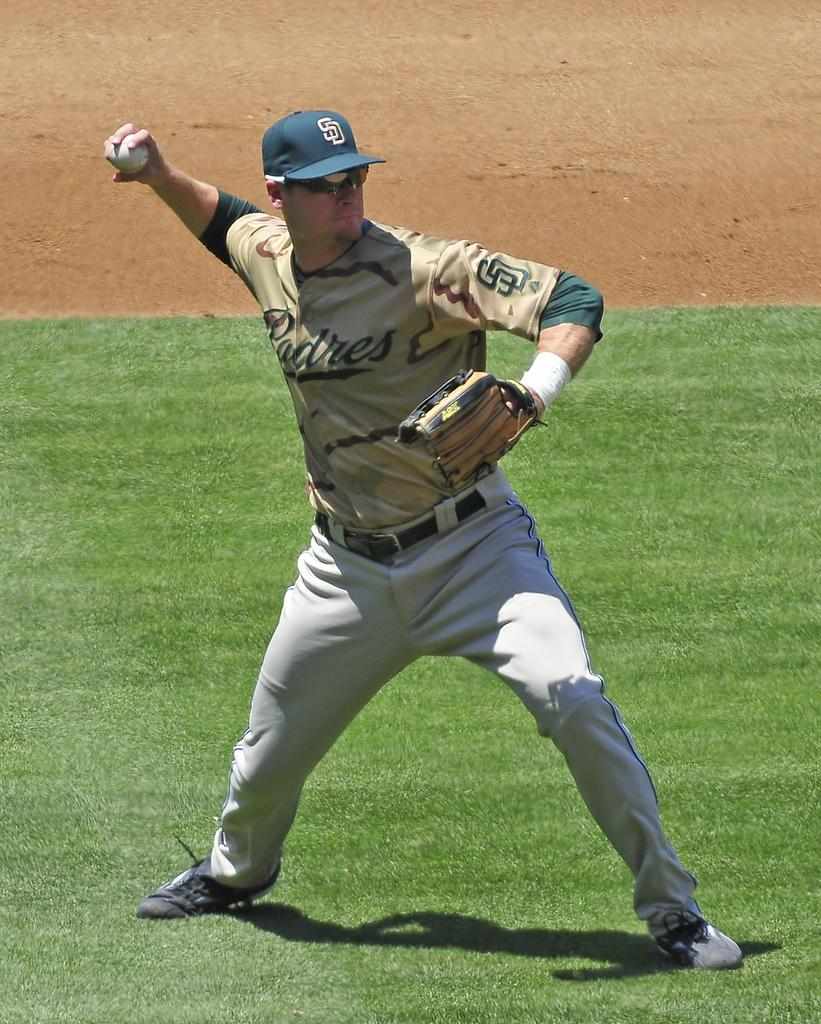Provide a one-sentence caption for the provided image. A man is wearing a Padres uniform on a baseball field. 